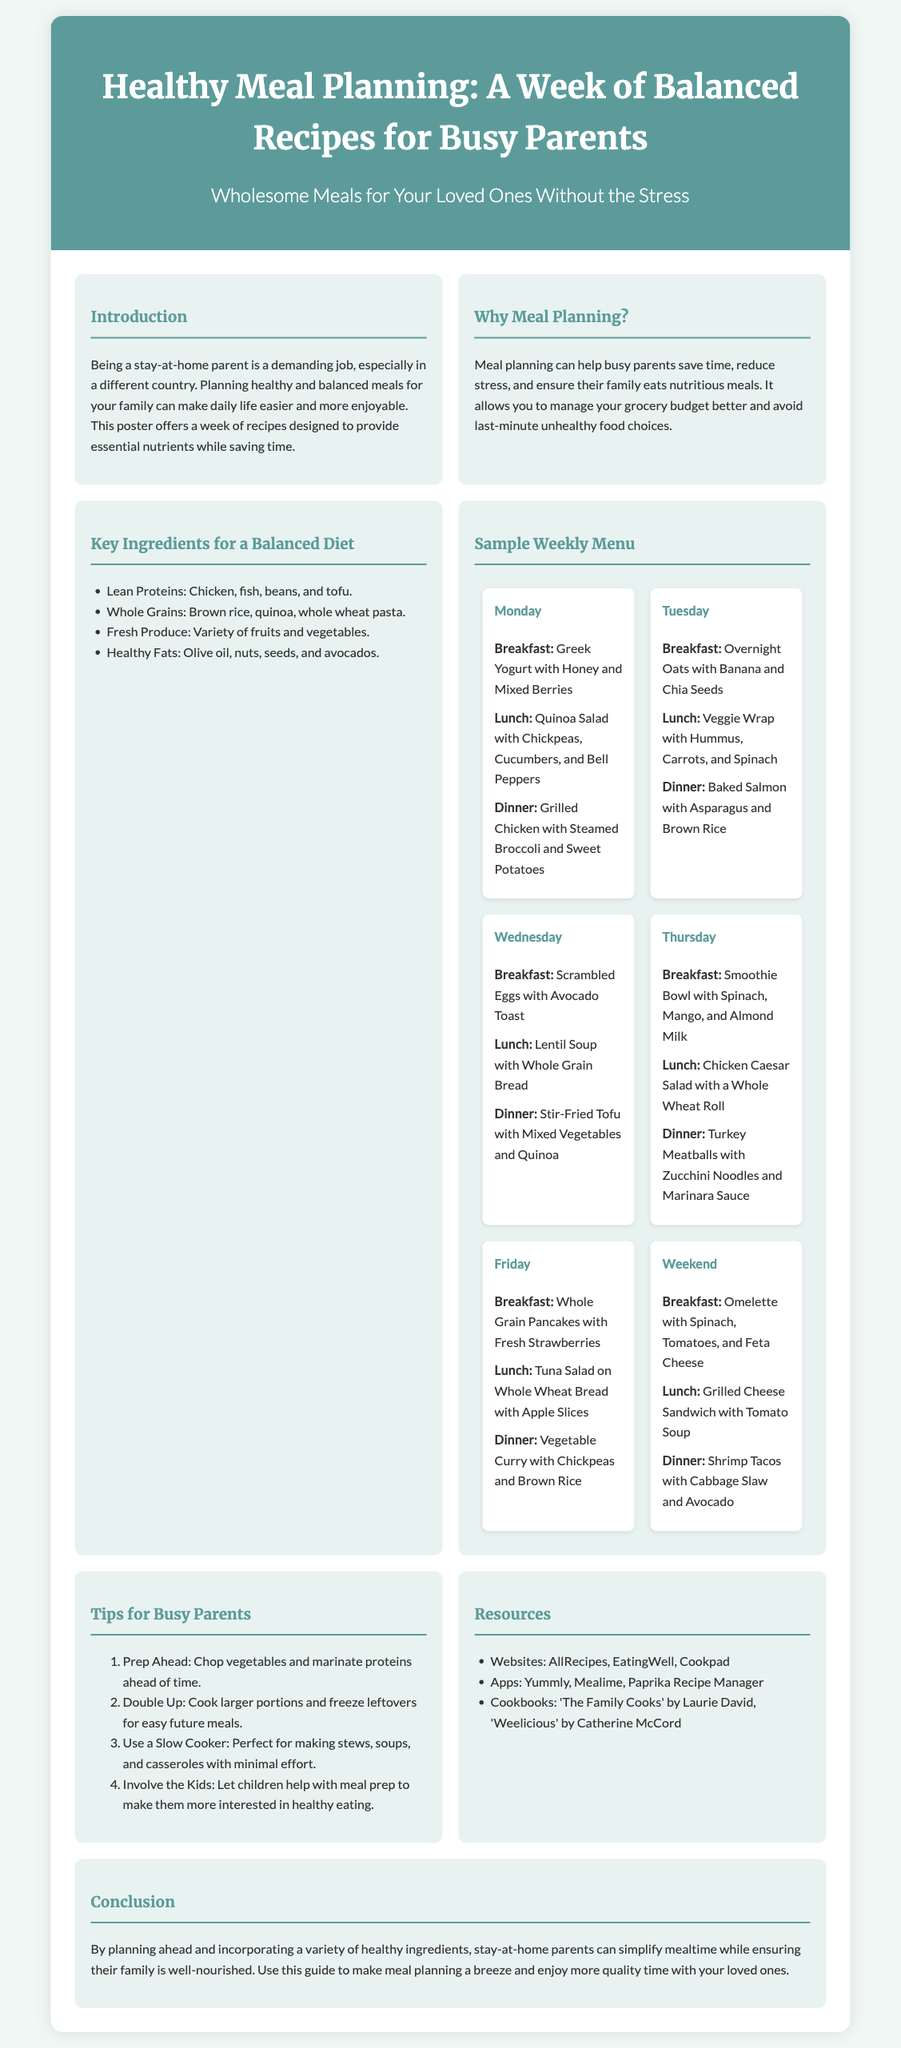What is the title of the poster? The title of the poster is stated prominently at the top of the document.
Answer: Healthy Meal Planning: A Week of Balanced Recipes for Busy Parents What day includes the meal “Baked Salmon with Asparagus and Brown Rice”? The days of the week are outlined with their corresponding meals in the sample weekly menu.
Answer: Tuesday What are two key ingredients listed for a balanced diet? The document provides a list of key ingredients for a balanced diet in a bulleted format.
Answer: Lean Proteins, Whole Grains How many meals are suggested for the weekend? The weekend section of the menu specifies the meals to be prepared.
Answer: Three What cooking method is suggested for busy parents? Tips for busy parents mention specific cooking methods suitable for meal preparation.
Answer: Slow Cooker What is one resource recommended for meal planning? Resources are provided in a list format within the document.
Answer: Yummly How many recipes are included in the sample weekly menu? The weekly menu comprises a set number of meals for each day of the week, counted in the document.
Answer: 21 What is the main benefit of meal planning mentioned? The benefits of meal planning are discussed in the introduction and other sections of the poster.
Answer: Save time 